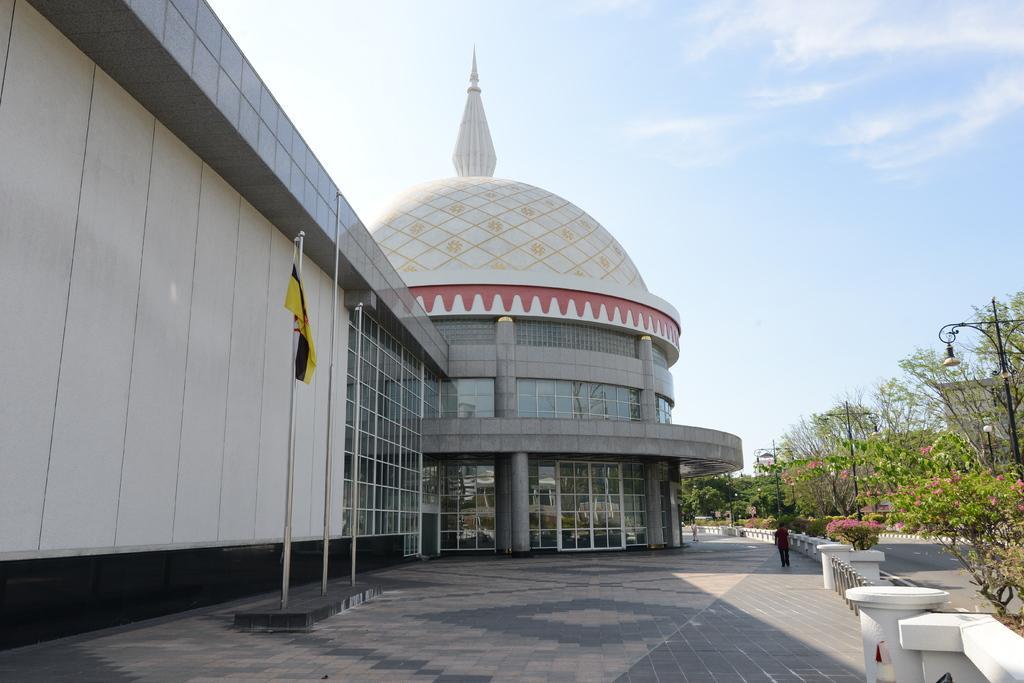Describe this image in one or two sentences. In this image, there is a building and we can see a tomb, at the right side there are some green color plants and trees, at the top there is a blue color sky. 